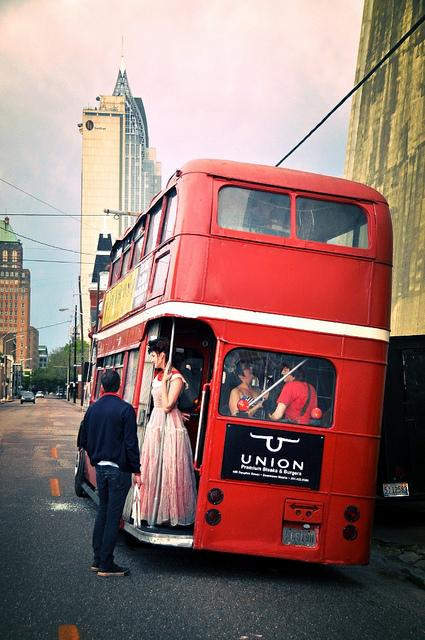What is the purpose of the wires above the vehicle? electricity 